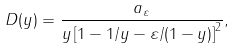Convert formula to latex. <formula><loc_0><loc_0><loc_500><loc_500>D ( y ) = \frac { a _ { \varepsilon } } { y \left [ 1 - 1 / y - \varepsilon / ( 1 - y ) \right ] ^ { 2 } } ,</formula> 